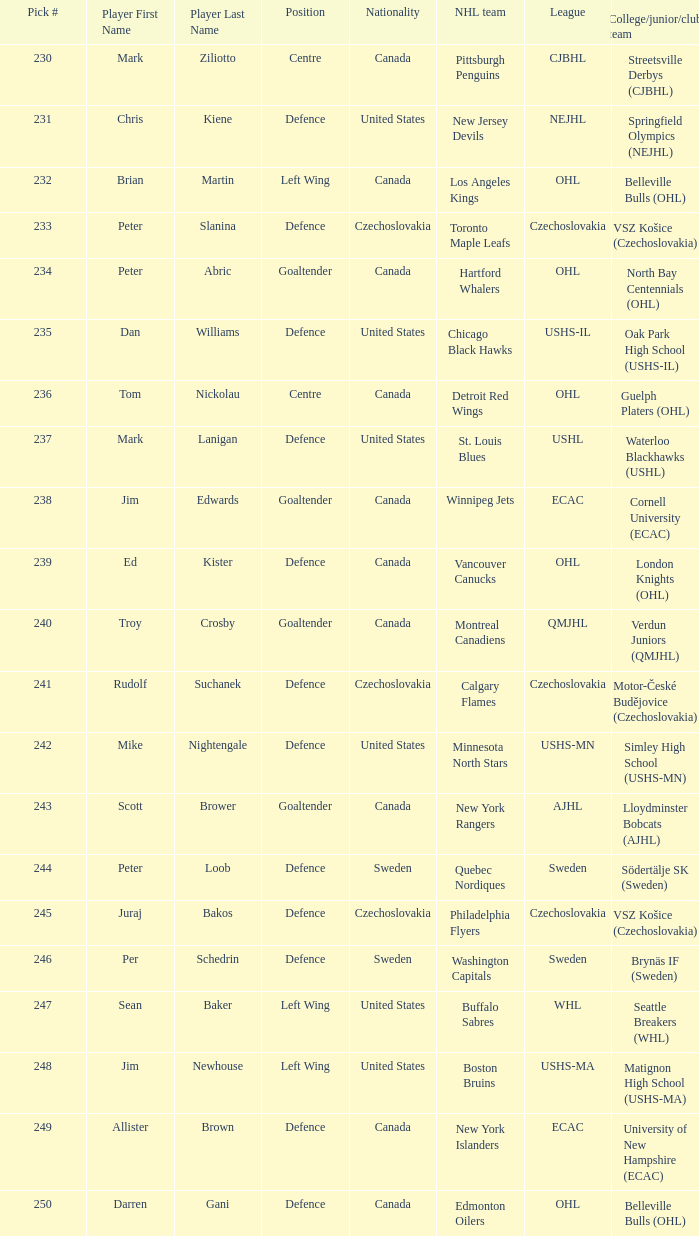What draft position did the new jersey devils obtain? 231.0. 